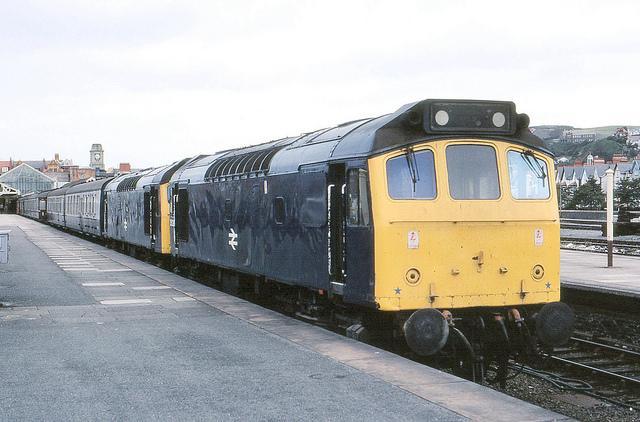Where is the train?
Concise answer only. On tracks. Is this a freight train?
Short answer required. No. What is the color of the train?
Short answer required. Yellow and black. 